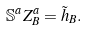Convert formula to latex. <formula><loc_0><loc_0><loc_500><loc_500>\mathbb { S } ^ { a } Z _ { B } ^ { a } = \tilde { h } _ { B } .</formula> 